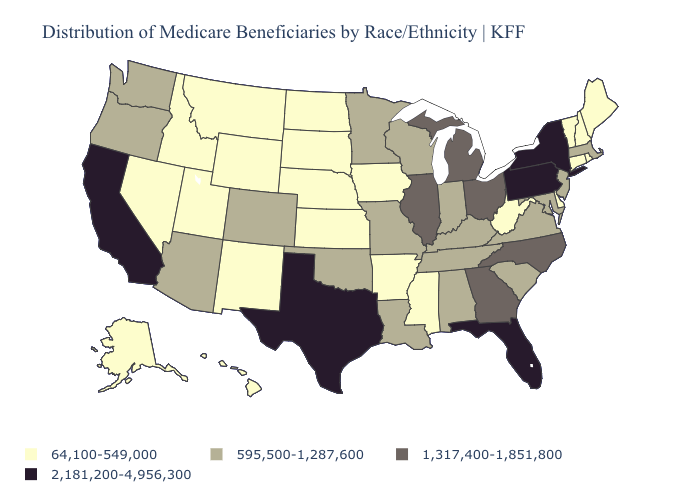Which states have the lowest value in the USA?
Be succinct. Alaska, Arkansas, Connecticut, Delaware, Hawaii, Idaho, Iowa, Kansas, Maine, Mississippi, Montana, Nebraska, Nevada, New Hampshire, New Mexico, North Dakota, Rhode Island, South Dakota, Utah, Vermont, West Virginia, Wyoming. Which states have the lowest value in the South?
Concise answer only. Arkansas, Delaware, Mississippi, West Virginia. Does New Mexico have a higher value than Virginia?
Give a very brief answer. No. What is the value of Utah?
Quick response, please. 64,100-549,000. Does the first symbol in the legend represent the smallest category?
Short answer required. Yes. Name the states that have a value in the range 595,500-1,287,600?
Be succinct. Alabama, Arizona, Colorado, Indiana, Kentucky, Louisiana, Maryland, Massachusetts, Minnesota, Missouri, New Jersey, Oklahoma, Oregon, South Carolina, Tennessee, Virginia, Washington, Wisconsin. Name the states that have a value in the range 2,181,200-4,956,300?
Be succinct. California, Florida, New York, Pennsylvania, Texas. Which states have the lowest value in the USA?
Keep it brief. Alaska, Arkansas, Connecticut, Delaware, Hawaii, Idaho, Iowa, Kansas, Maine, Mississippi, Montana, Nebraska, Nevada, New Hampshire, New Mexico, North Dakota, Rhode Island, South Dakota, Utah, Vermont, West Virginia, Wyoming. Does Wyoming have the highest value in the USA?
Concise answer only. No. What is the highest value in the MidWest ?
Give a very brief answer. 1,317,400-1,851,800. Name the states that have a value in the range 595,500-1,287,600?
Write a very short answer. Alabama, Arizona, Colorado, Indiana, Kentucky, Louisiana, Maryland, Massachusetts, Minnesota, Missouri, New Jersey, Oklahoma, Oregon, South Carolina, Tennessee, Virginia, Washington, Wisconsin. What is the lowest value in the Northeast?
Be succinct. 64,100-549,000. Does Wyoming have the same value as Illinois?
Give a very brief answer. No. Does Nevada have a lower value than Utah?
Be succinct. No. Among the states that border New Jersey , which have the lowest value?
Write a very short answer. Delaware. 